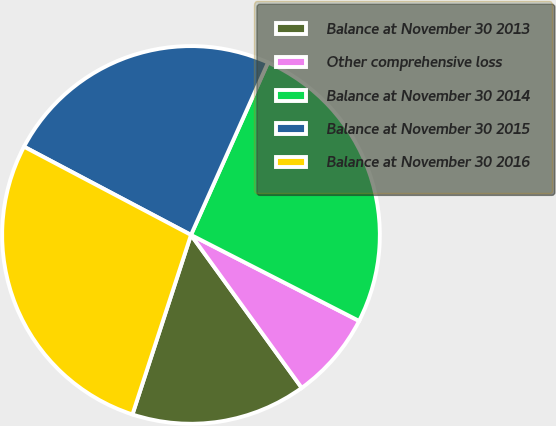Convert chart to OTSL. <chart><loc_0><loc_0><loc_500><loc_500><pie_chart><fcel>Balance at November 30 2013<fcel>Other comprehensive loss<fcel>Balance at November 30 2014<fcel>Balance at November 30 2015<fcel>Balance at November 30 2016<nl><fcel>14.99%<fcel>7.5%<fcel>25.84%<fcel>23.95%<fcel>27.72%<nl></chart> 